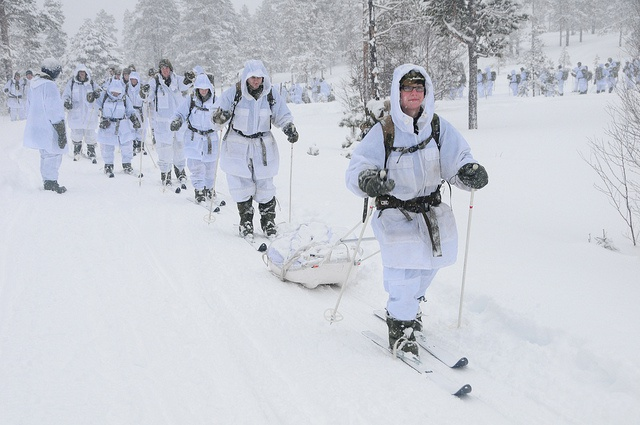Describe the objects in this image and their specific colors. I can see people in gray, darkgray, and lavender tones, people in gray, darkgray, and lavender tones, people in gray, lightgray, darkgray, and lavender tones, people in gray and lavender tones, and people in gray and lavender tones in this image. 